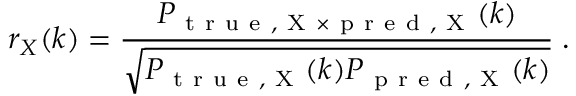Convert formula to latex. <formula><loc_0><loc_0><loc_500><loc_500>r _ { X } ( k ) = \frac { P _ { t r u e , X \times p r e d , X } ( k ) } { \sqrt { P _ { t r u e , X } ( k ) P _ { p r e d , X } ( k ) } } \, .</formula> 